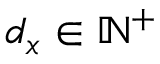<formula> <loc_0><loc_0><loc_500><loc_500>d _ { x } \in \mathbb { N } ^ { + }</formula> 